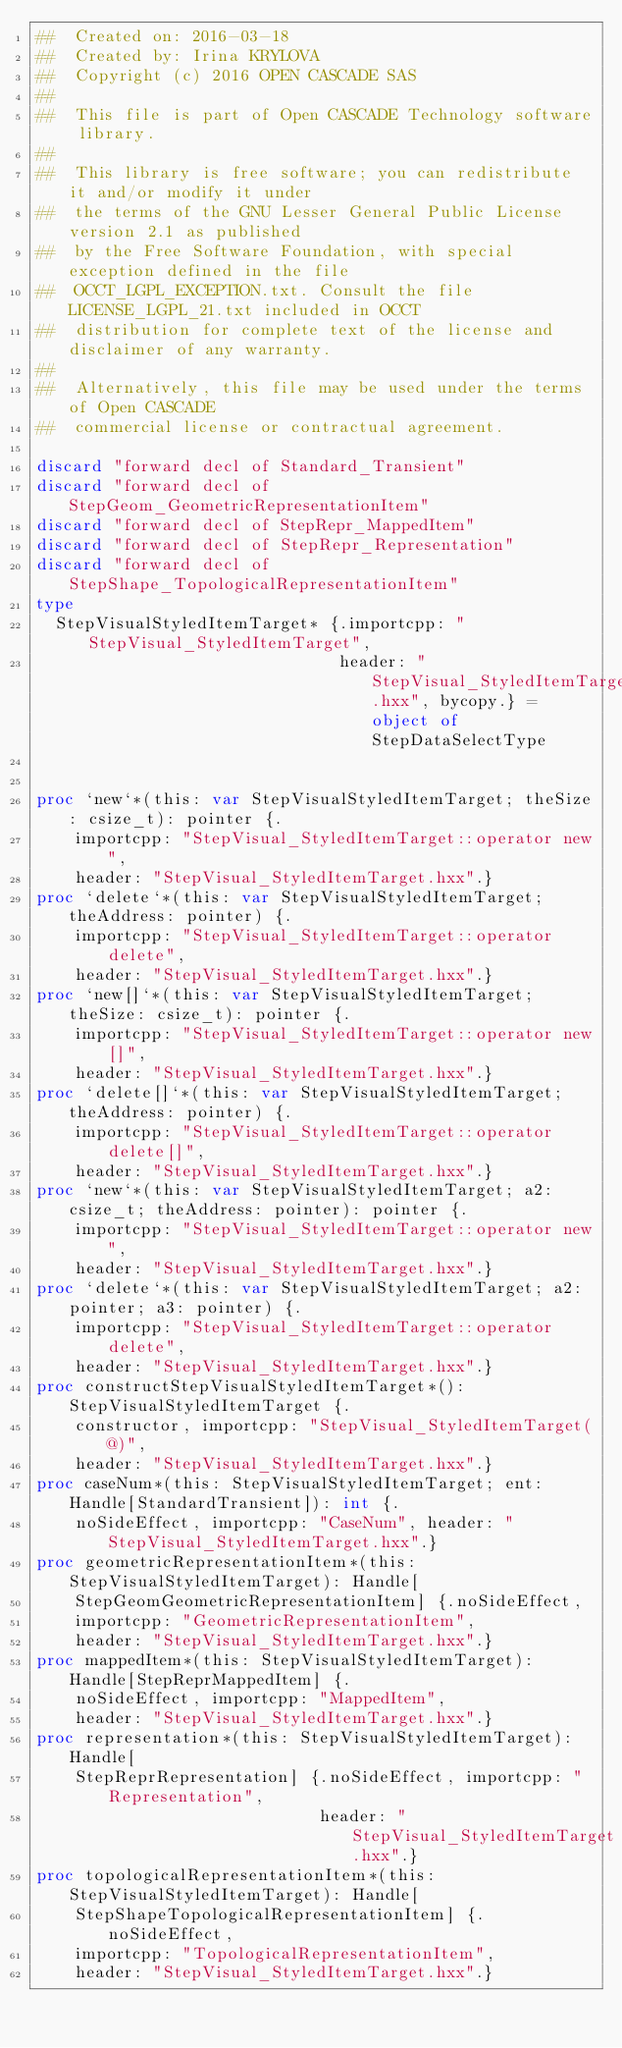<code> <loc_0><loc_0><loc_500><loc_500><_Nim_>##  Created on: 2016-03-18
##  Created by: Irina KRYLOVA
##  Copyright (c) 2016 OPEN CASCADE SAS
##
##  This file is part of Open CASCADE Technology software library.
##
##  This library is free software; you can redistribute it and/or modify it under
##  the terms of the GNU Lesser General Public License version 2.1 as published
##  by the Free Software Foundation, with special exception defined in the file
##  OCCT_LGPL_EXCEPTION.txt. Consult the file LICENSE_LGPL_21.txt included in OCCT
##  distribution for complete text of the license and disclaimer of any warranty.
##
##  Alternatively, this file may be used under the terms of Open CASCADE
##  commercial license or contractual agreement.

discard "forward decl of Standard_Transient"
discard "forward decl of StepGeom_GeometricRepresentationItem"
discard "forward decl of StepRepr_MappedItem"
discard "forward decl of StepRepr_Representation"
discard "forward decl of StepShape_TopologicalRepresentationItem"
type
  StepVisualStyledItemTarget* {.importcpp: "StepVisual_StyledItemTarget",
                               header: "StepVisual_StyledItemTarget.hxx", bycopy.} = object of StepDataSelectType


proc `new`*(this: var StepVisualStyledItemTarget; theSize: csize_t): pointer {.
    importcpp: "StepVisual_StyledItemTarget::operator new",
    header: "StepVisual_StyledItemTarget.hxx".}
proc `delete`*(this: var StepVisualStyledItemTarget; theAddress: pointer) {.
    importcpp: "StepVisual_StyledItemTarget::operator delete",
    header: "StepVisual_StyledItemTarget.hxx".}
proc `new[]`*(this: var StepVisualStyledItemTarget; theSize: csize_t): pointer {.
    importcpp: "StepVisual_StyledItemTarget::operator new[]",
    header: "StepVisual_StyledItemTarget.hxx".}
proc `delete[]`*(this: var StepVisualStyledItemTarget; theAddress: pointer) {.
    importcpp: "StepVisual_StyledItemTarget::operator delete[]",
    header: "StepVisual_StyledItemTarget.hxx".}
proc `new`*(this: var StepVisualStyledItemTarget; a2: csize_t; theAddress: pointer): pointer {.
    importcpp: "StepVisual_StyledItemTarget::operator new",
    header: "StepVisual_StyledItemTarget.hxx".}
proc `delete`*(this: var StepVisualStyledItemTarget; a2: pointer; a3: pointer) {.
    importcpp: "StepVisual_StyledItemTarget::operator delete",
    header: "StepVisual_StyledItemTarget.hxx".}
proc constructStepVisualStyledItemTarget*(): StepVisualStyledItemTarget {.
    constructor, importcpp: "StepVisual_StyledItemTarget(@)",
    header: "StepVisual_StyledItemTarget.hxx".}
proc caseNum*(this: StepVisualStyledItemTarget; ent: Handle[StandardTransient]): int {.
    noSideEffect, importcpp: "CaseNum", header: "StepVisual_StyledItemTarget.hxx".}
proc geometricRepresentationItem*(this: StepVisualStyledItemTarget): Handle[
    StepGeomGeometricRepresentationItem] {.noSideEffect,
    importcpp: "GeometricRepresentationItem",
    header: "StepVisual_StyledItemTarget.hxx".}
proc mappedItem*(this: StepVisualStyledItemTarget): Handle[StepReprMappedItem] {.
    noSideEffect, importcpp: "MappedItem",
    header: "StepVisual_StyledItemTarget.hxx".}
proc representation*(this: StepVisualStyledItemTarget): Handle[
    StepReprRepresentation] {.noSideEffect, importcpp: "Representation",
                             header: "StepVisual_StyledItemTarget.hxx".}
proc topologicalRepresentationItem*(this: StepVisualStyledItemTarget): Handle[
    StepShapeTopologicalRepresentationItem] {.noSideEffect,
    importcpp: "TopologicalRepresentationItem",
    header: "StepVisual_StyledItemTarget.hxx".}</code> 